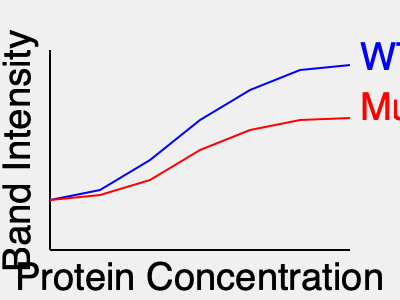Based on the EMSA results shown in the graph, which DNA-binding protein (wild-type or mutant) has a higher affinity for its target DNA sequence, and what does this suggest about the effect of the mutation on protein function? To analyze the EMSA results and determine which protein has a higher affinity for the target DNA sequence, we need to follow these steps:

1. Interpret the graph:
   - The x-axis represents increasing protein concentration.
   - The y-axis represents band intensity, which correlates with the amount of protein-DNA complexes formed.
   - The blue line represents the wild-type (WT) protein.
   - The red line represents the mutant protein.

2. Compare the curves:
   - The WT protein (blue) shows a steeper curve that reaches a higher maximum band intensity.
   - The mutant protein (red) shows a shallower curve that reaches a lower maximum band intensity.

3. Analyze protein-DNA binding:
   - A steeper curve indicates that protein-DNA complexes form more readily at lower protein concentrations.
   - A higher maximum band intensity suggests more protein-DNA complexes are formed overall.

4. Determine relative affinities:
   - The WT protein forms more complexes at lower concentrations, indicating higher affinity.
   - The mutant protein requires higher concentrations to form complexes, indicating lower affinity.

5. Interpret the effect of the mutation:
   - The mutation appears to reduce the protein's ability to bind to its target DNA sequence.
   - This suggests that the mutation likely occurs in a region important for DNA binding, such as the DNA-binding domain.

6. Consider functional implications:
   - Reduced DNA-binding affinity may lead to decreased transcriptional regulation if the protein is a transcription factor.
   - The mutation could result in loss of function or reduced activity of the protein in vivo.
Answer: Wild-type protein has higher affinity; mutation likely impairs DNA-binding function. 